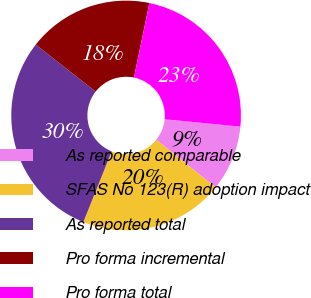Convert chart to OTSL. <chart><loc_0><loc_0><loc_500><loc_500><pie_chart><fcel>As reported comparable<fcel>SFAS No 123(R) adoption impact<fcel>As reported total<fcel>Pro forma incremental<fcel>Pro forma total<nl><fcel>9.23%<fcel>20.29%<fcel>29.52%<fcel>17.66%<fcel>23.3%<nl></chart> 